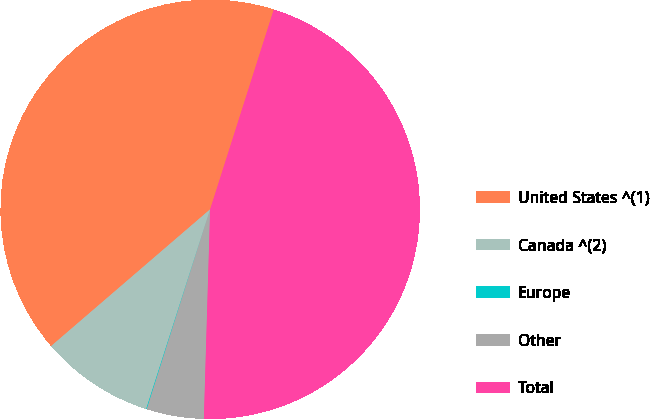<chart> <loc_0><loc_0><loc_500><loc_500><pie_chart><fcel>United States ^(1)<fcel>Canada ^(2)<fcel>Europe<fcel>Other<fcel>Total<nl><fcel>41.21%<fcel>8.76%<fcel>0.05%<fcel>4.41%<fcel>45.57%<nl></chart> 